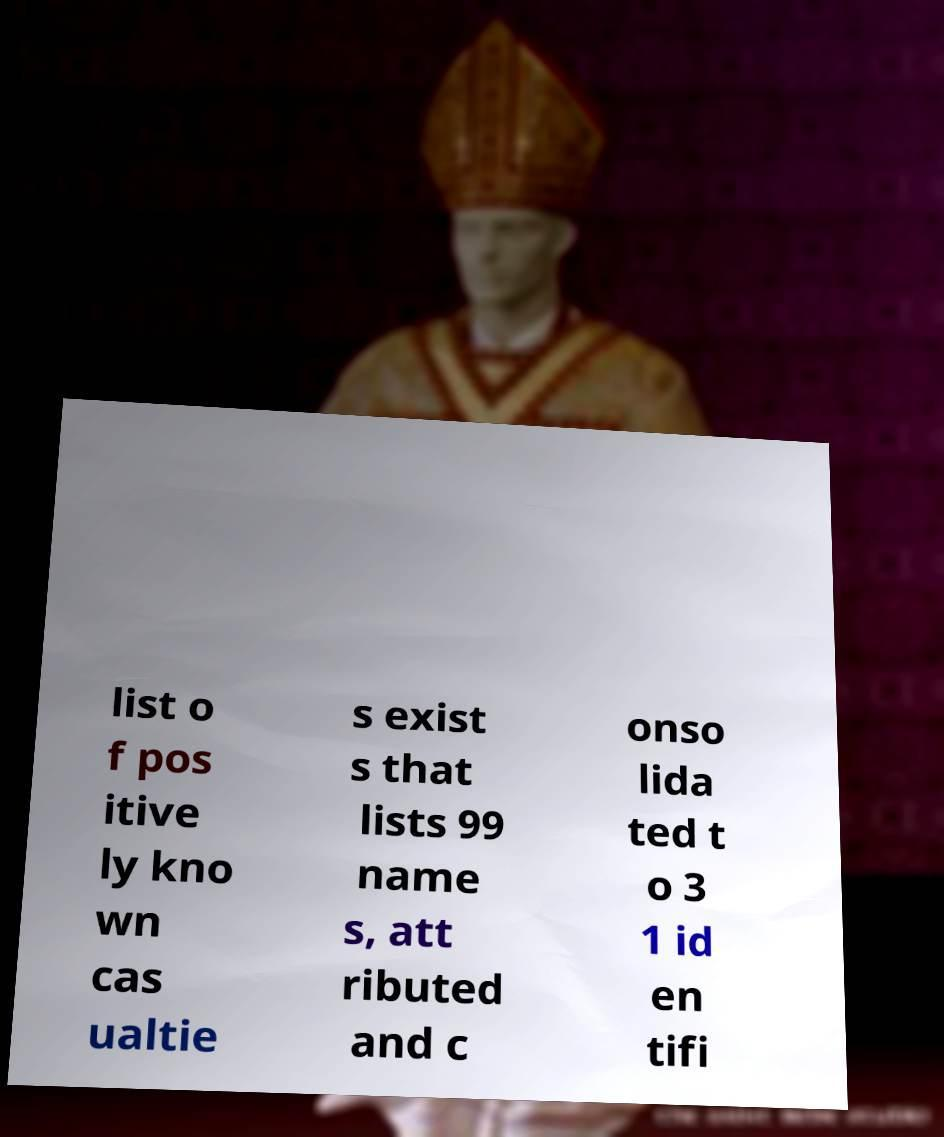Please identify and transcribe the text found in this image. list o f pos itive ly kno wn cas ualtie s exist s that lists 99 name s, att ributed and c onso lida ted t o 3 1 id en tifi 